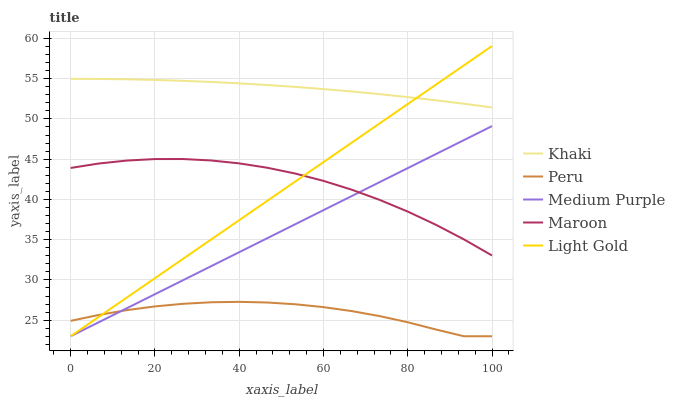Does Peru have the minimum area under the curve?
Answer yes or no. Yes. Does Khaki have the maximum area under the curve?
Answer yes or no. Yes. Does Light Gold have the minimum area under the curve?
Answer yes or no. No. Does Light Gold have the maximum area under the curve?
Answer yes or no. No. Is Medium Purple the smoothest?
Answer yes or no. Yes. Is Maroon the roughest?
Answer yes or no. Yes. Is Khaki the smoothest?
Answer yes or no. No. Is Khaki the roughest?
Answer yes or no. No. Does Medium Purple have the lowest value?
Answer yes or no. Yes. Does Khaki have the lowest value?
Answer yes or no. No. Does Light Gold have the highest value?
Answer yes or no. Yes. Does Khaki have the highest value?
Answer yes or no. No. Is Peru less than Maroon?
Answer yes or no. Yes. Is Maroon greater than Peru?
Answer yes or no. Yes. Does Medium Purple intersect Light Gold?
Answer yes or no. Yes. Is Medium Purple less than Light Gold?
Answer yes or no. No. Is Medium Purple greater than Light Gold?
Answer yes or no. No. Does Peru intersect Maroon?
Answer yes or no. No. 